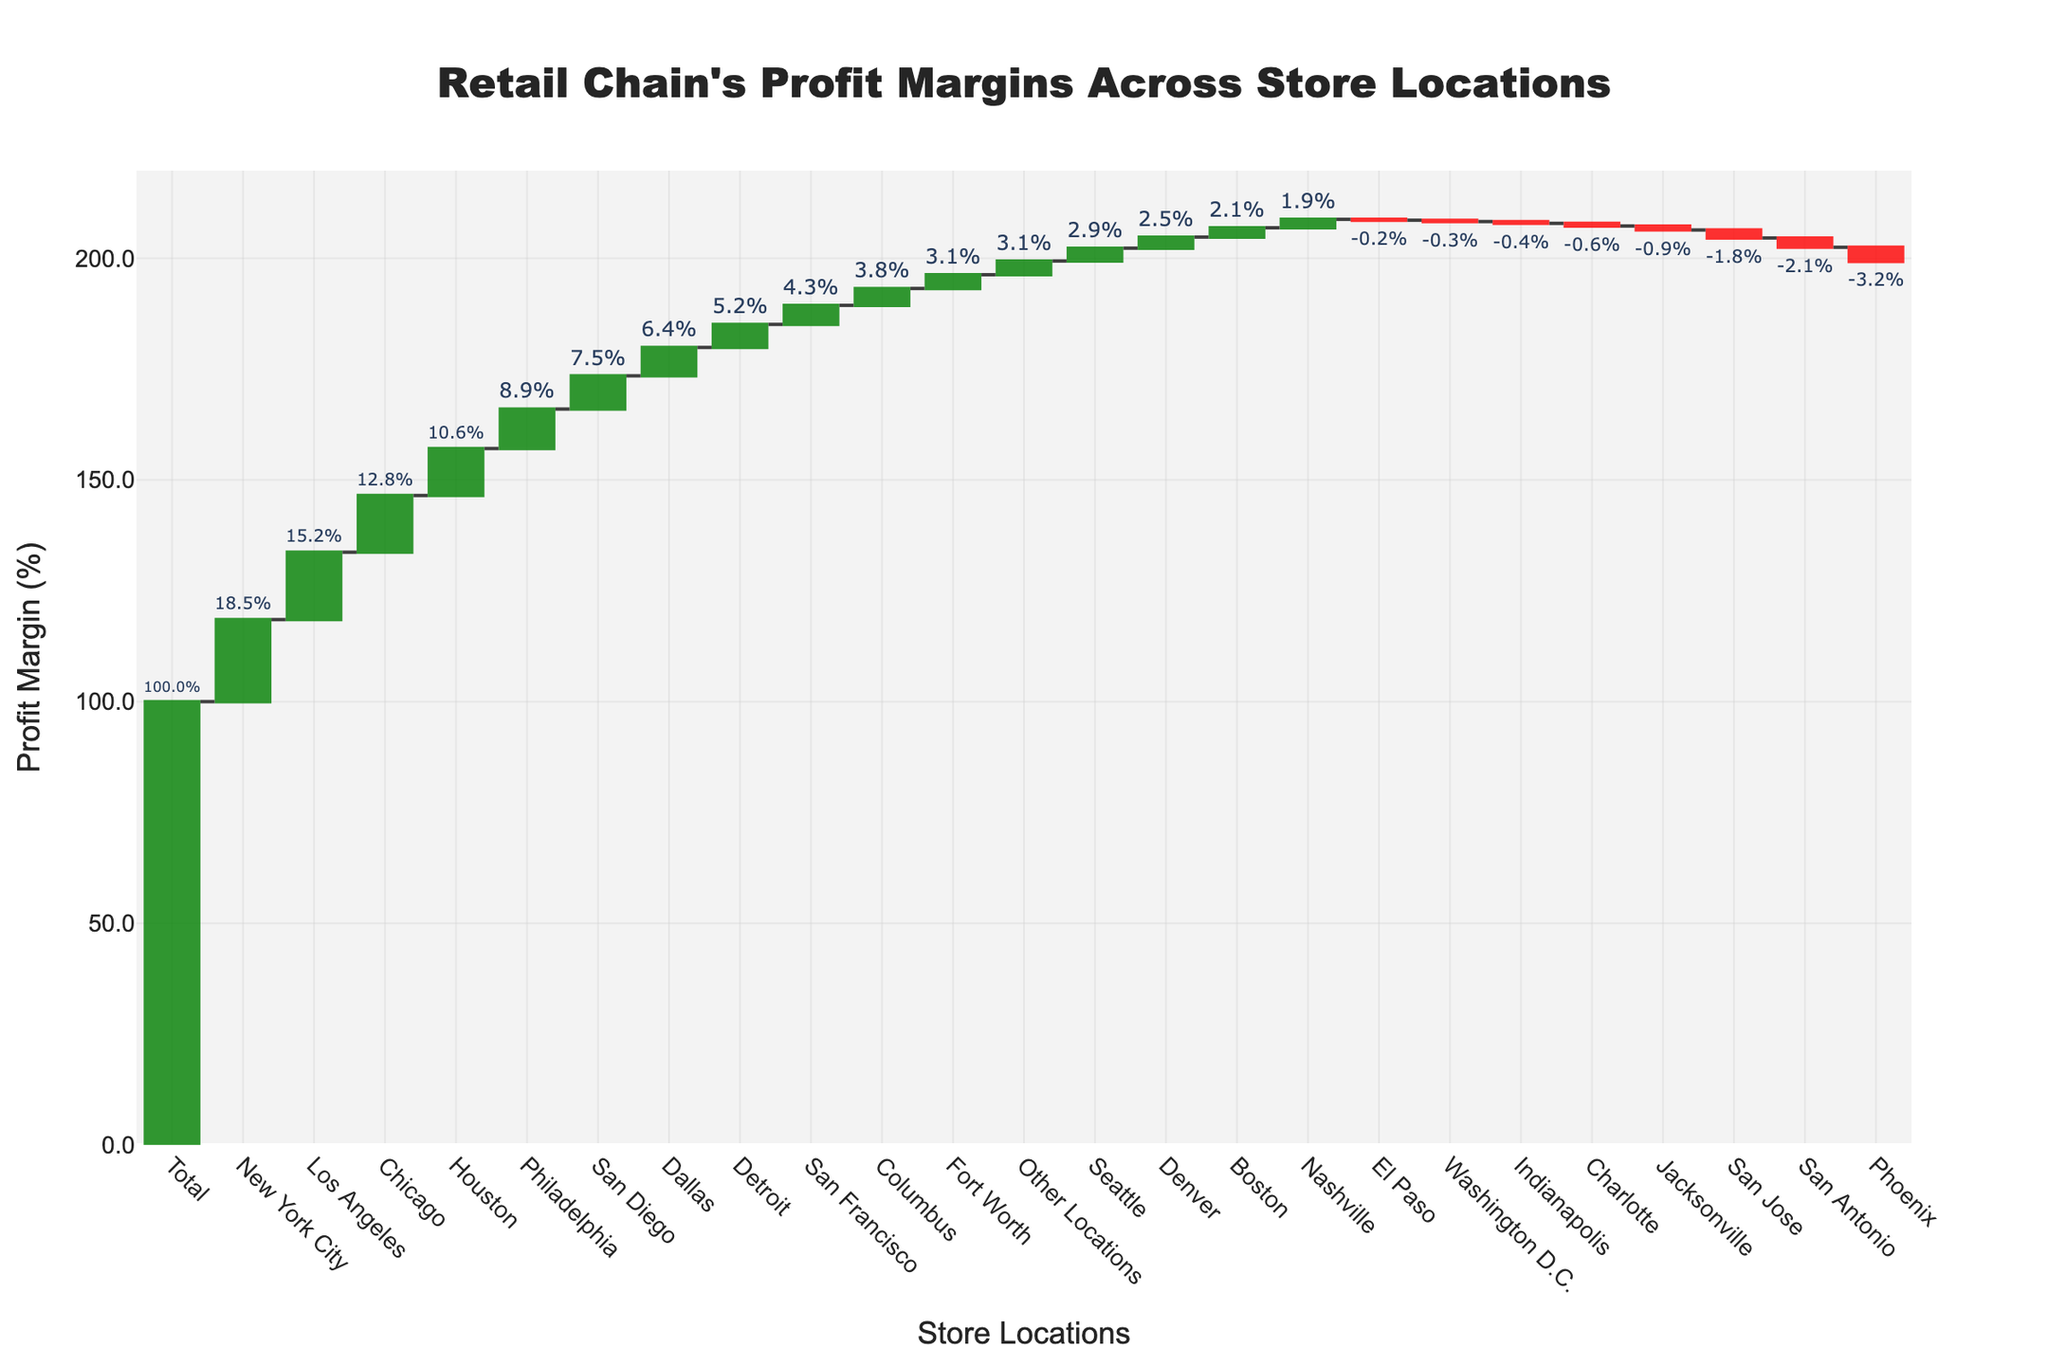What is the total profit margin across all store locations? According to the figure, the total profit margin is shown in the "Total" column, which sums up all individual profit contributions from each store location.
Answer: 100% How many store locations have a negative profit margin? The figure uses red bars to represent store locations with negative profit margins. By visually counting, we can determine the number of these locations.
Answer: 8 Which store location has the highest profit margin? The highest profit margin is represented by the tallest green bar in the figure.
Answer: New York City What is the combined profit margin of New York City, Los Angeles, and Chicago? Add the individual profit margins of these three store locations: 18.5% + 15.2% + 12.8%.
Answer: 46.5% Is Phoenix more or less profitable than San Antonio? By comparing the heights and colors of the bars for Phoenix and San Antonio, since both are red and represent negative values, we need to compare the absolute values. Phoenix (-3.2%) is more negative than San Antonio (-2.1%), so Phoenix is less profitable.
Answer: Less profitable What is the relative difference in profit margin between Philadelphia and Dallas? Find the profit margin for Philadelphia and Dallas from the figure. Then, subtract the smaller from the larger value: 8.9% - 6.4%.
Answer: 2.5% Which store location has the smallest negative profit margin? The smallest negative profit is represented by the shortest red bar.
Answer: Indianapolis How many store locations contribute positively to the total profit margin? The positive contributions are represented by green bars. By visually counting the green bars, we find the number of such locations.
Answer: 14 What is the cumulative profit margin at the midpoint (after the first 10 stores)? Sum the profit margins of the first 10 store locations as represented in the figure to find the cumulative value at that point. The first 10 locations are ordered highest to lowest: 18.5% (NYC) + 15.2% (LA) + 12.8% (Chicago) + 10.6% (Houston) + 8.9% (Philadelphia) + 7.5% (San Diego) + 6.4% (Dallas) + (-1.8%) (San Jose) + 5.2% (Detroit) + (-0.9%) (Jacksonville).
Answer: 82.4% By what percentage does Houston's profit margin exceed that of Seattle? Refer to the profit margins for Houston and Seattle. The profit exceedance can be calculated as the difference divided by Seattle’s margin: (10.6% - 2.9%) / 2.9% = 2.655 or 265.5%.
Answer: 265.5% 